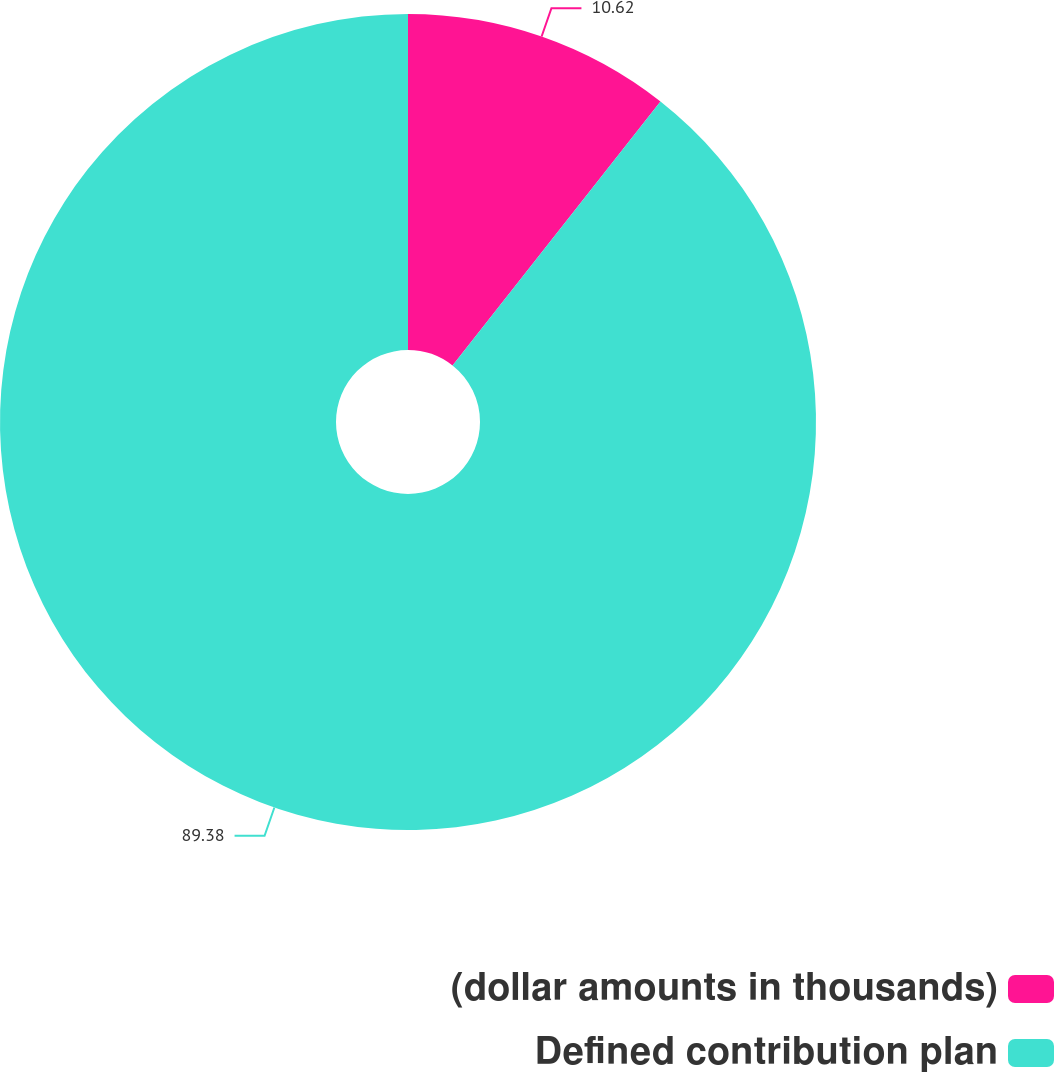<chart> <loc_0><loc_0><loc_500><loc_500><pie_chart><fcel>(dollar amounts in thousands)<fcel>Defined contribution plan<nl><fcel>10.62%<fcel>89.38%<nl></chart> 